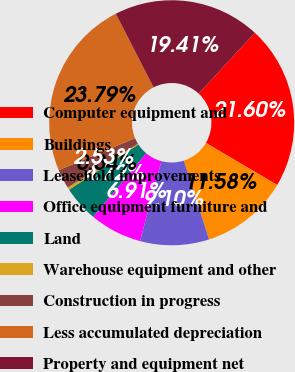Convert chart to OTSL. <chart><loc_0><loc_0><loc_500><loc_500><pie_chart><fcel>Computer equipment and<fcel>Buildings<fcel>Leasehold improvements<fcel>Office equipment furniture and<fcel>Land<fcel>Warehouse equipment and other<fcel>Construction in progress<fcel>Less accumulated depreciation<fcel>Property and equipment net<nl><fcel>21.6%<fcel>11.58%<fcel>9.1%<fcel>6.91%<fcel>4.72%<fcel>0.34%<fcel>2.53%<fcel>23.79%<fcel>19.41%<nl></chart> 